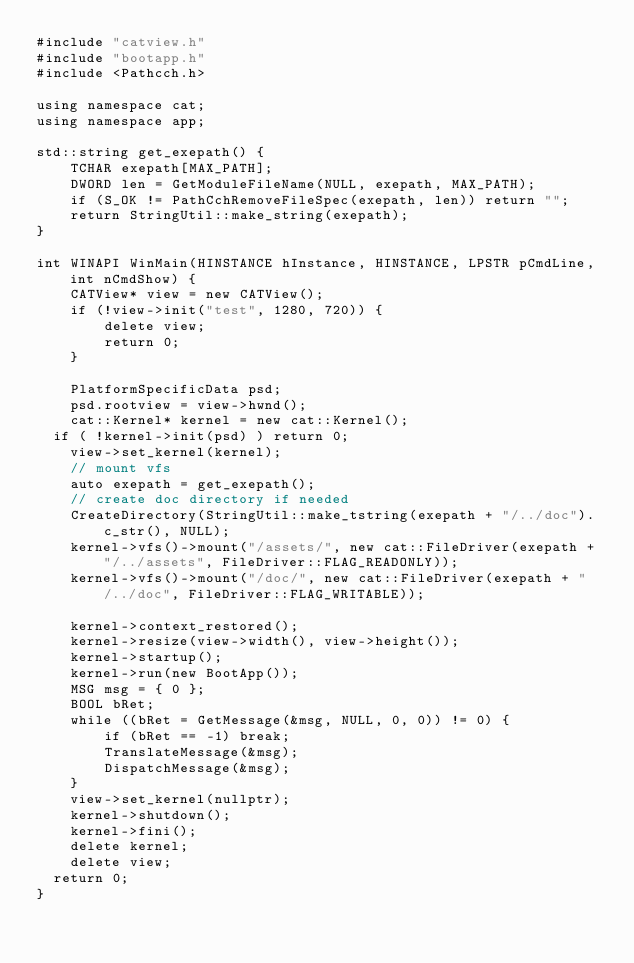Convert code to text. <code><loc_0><loc_0><loc_500><loc_500><_C++_>#include "catview.h"
#include "bootapp.h"
#include <Pathcch.h>

using namespace cat;
using namespace app;

std::string get_exepath() {
    TCHAR exepath[MAX_PATH];
    DWORD len = GetModuleFileName(NULL, exepath, MAX_PATH);
    if (S_OK != PathCchRemoveFileSpec(exepath, len)) return "";
    return StringUtil::make_string(exepath);
}

int WINAPI WinMain(HINSTANCE hInstance, HINSTANCE, LPSTR pCmdLine, int nCmdShow) {
    CATView* view = new CATView();
    if (!view->init("test", 1280, 720)) {
        delete view;
        return 0;
    }

    PlatformSpecificData psd;
    psd.rootview = view->hwnd();
    cat::Kernel* kernel = new cat::Kernel();
	if ( !kernel->init(psd) ) return 0;
    view->set_kernel(kernel);
    // mount vfs
    auto exepath = get_exepath();
    // create doc directory if needed
    CreateDirectory(StringUtil::make_tstring(exepath + "/../doc").c_str(), NULL);
    kernel->vfs()->mount("/assets/", new cat::FileDriver(exepath + "/../assets", FileDriver::FLAG_READONLY));
    kernel->vfs()->mount("/doc/", new cat::FileDriver(exepath + "/../doc", FileDriver::FLAG_WRITABLE));

    kernel->context_restored();
    kernel->resize(view->width(), view->height());
    kernel->startup();
    kernel->run(new BootApp());
    MSG msg = { 0 };
    BOOL bRet;
    while ((bRet = GetMessage(&msg, NULL, 0, 0)) != 0) {
        if (bRet == -1) break;
        TranslateMessage(&msg);
        DispatchMessage(&msg);
    }
    view->set_kernel(nullptr);
    kernel->shutdown();
    kernel->fini();
    delete kernel;
    delete view;
	return 0;
}

</code> 